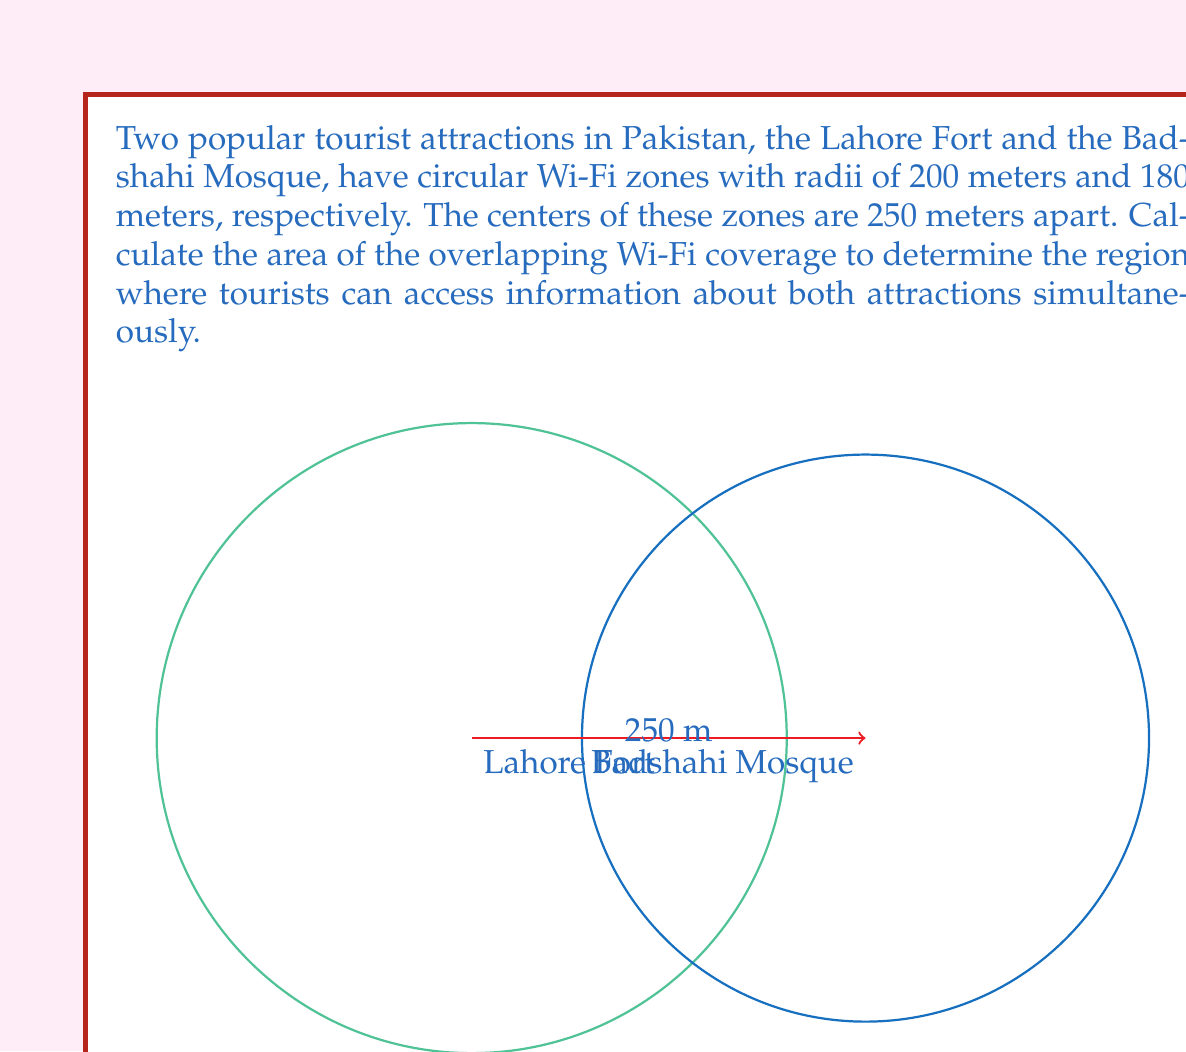Give your solution to this math problem. To find the area of overlap between two circles, we'll use the following steps:

1) First, we need to calculate the distance $d$ between the centers of the circles. We're given this as 250 meters.

2) Next, we'll use the formula for the area of the lens-shaped overlap:

   $$A = r_1^2 \arccos(\frac{d^2 + r_1^2 - r_2^2}{2dr_1}) + r_2^2 \arccos(\frac{d^2 + r_2^2 - r_1^2}{2dr_2}) - \frac{1}{2}\sqrt{(-d+r_1+r_2)(d+r_1-r_2)(d-r_1+r_2)(d+r_1+r_2)}$$

   Where $r_1$ and $r_2$ are the radii of the circles, and $d$ is the distance between their centers.

3) Let's substitute our values:
   $r_1 = 200$, $r_2 = 180$, $d = 250$

4) Calculating each part:

   $\arccos(\frac{250^2 + 200^2 - 180^2}{2 \cdot 250 \cdot 200}) \approx 1.0472$
   
   $\arccos(\frac{250^2 + 180^2 - 200^2}{2 \cdot 250 \cdot 180}) \approx 1.2490$
   
   $\sqrt{(-250+200+180)(250+200-180)(250-200+180)(250+200+180)} \approx 224.4994$

5) Putting it all together:

   $A = 200^2 \cdot 1.0472 + 180^2 \cdot 1.2490 - \frac{1}{2} \cdot 224.4994$
   
   $A = 41888 + 40464 - 112.2497$
   
   $A = 82239.7503$ square meters

6) Rounding to the nearest whole number:

   $A \approx 82240$ square meters
Answer: $82240$ m² 